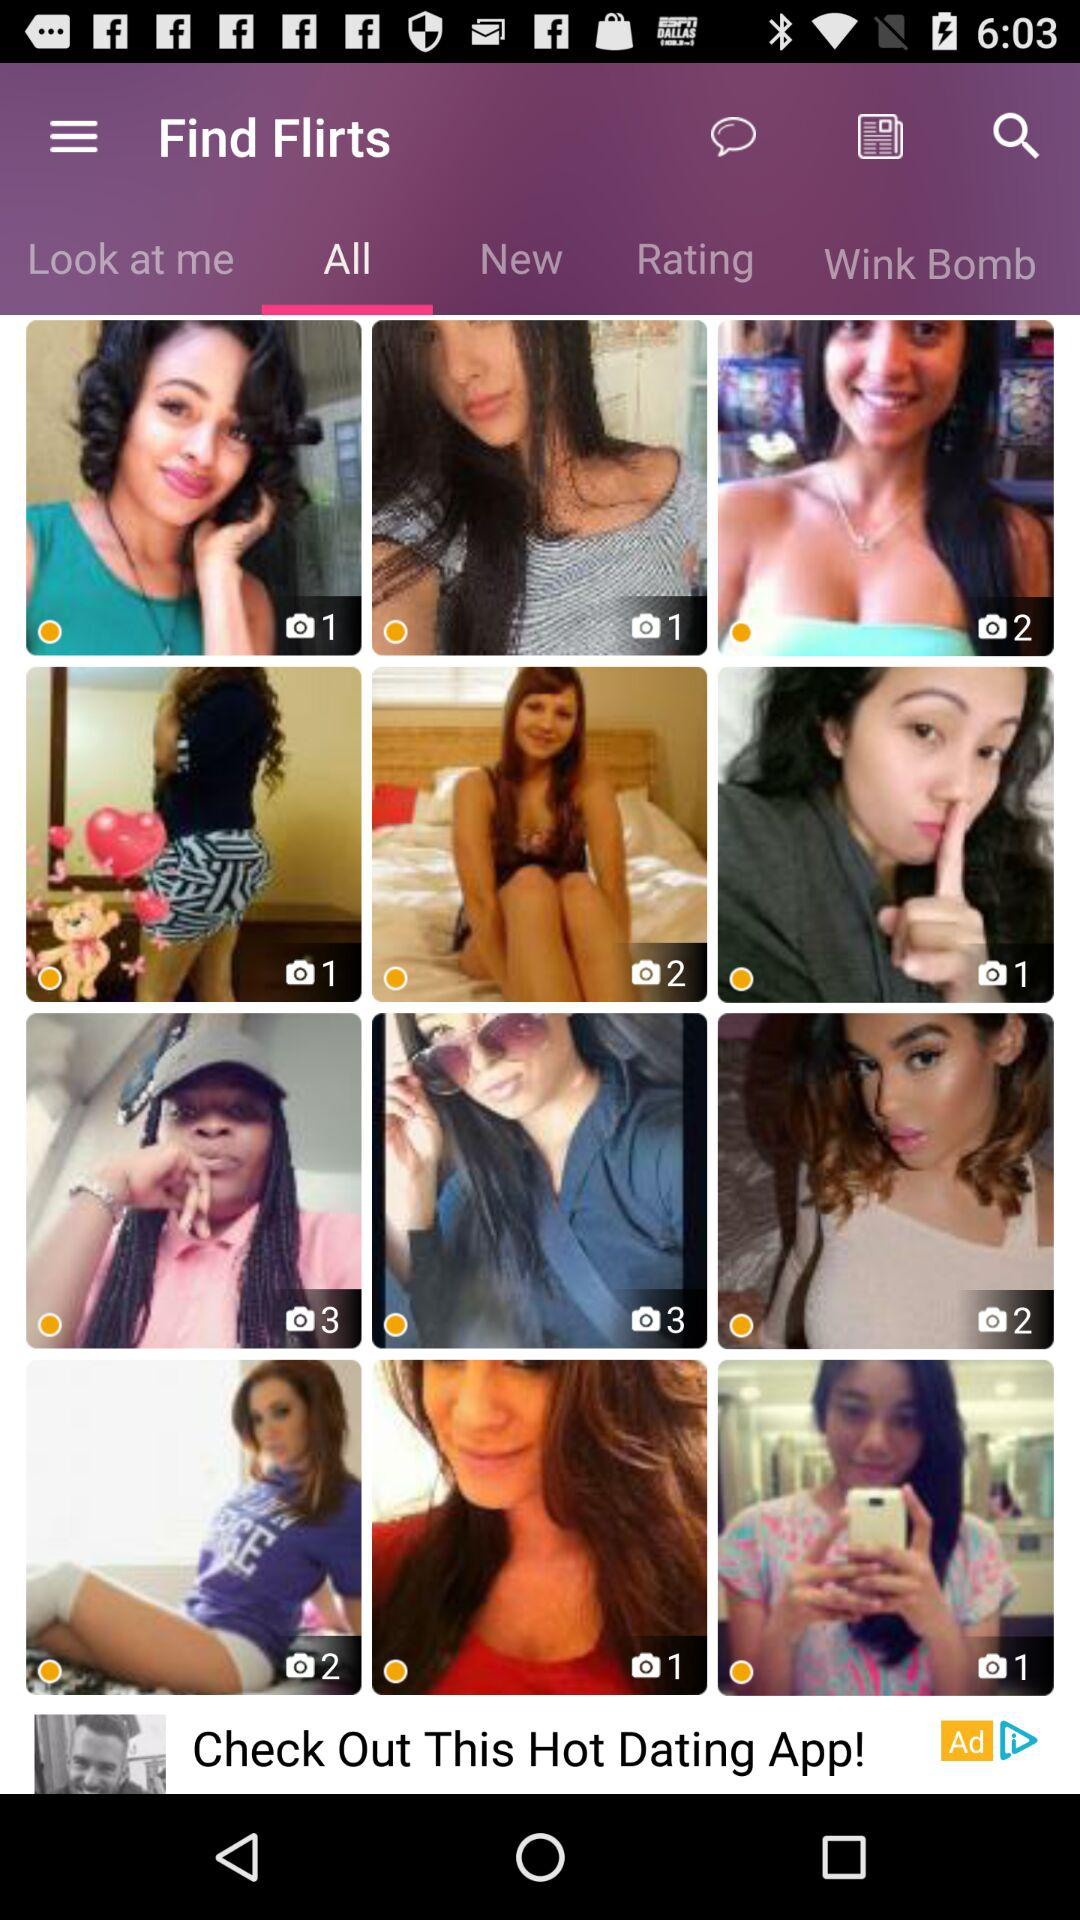Which tab is selected? The selected tab is "All". 